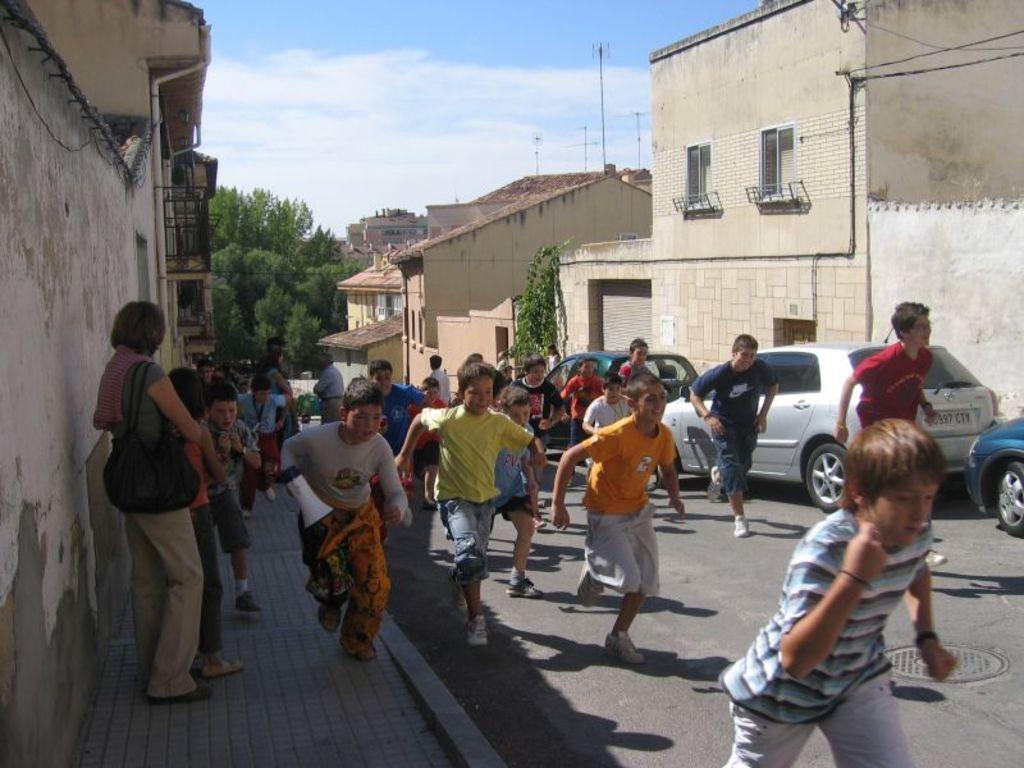Please provide a concise description of this image. This is the picture of a city. In this image there are group of people running on the road and on the footpath, there are two persons standing on the footpath. There are vehicles on the road and there is a manhole on the road. At the back there are buildings, trees and poles. At the top there is sky and there are clouds. At the bottom there is a road. 